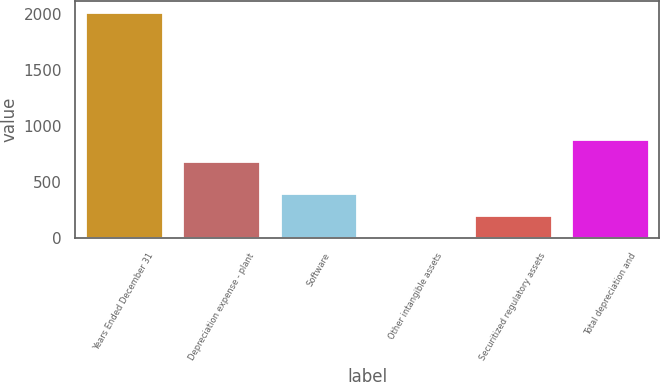Convert chart. <chart><loc_0><loc_0><loc_500><loc_500><bar_chart><fcel>Years Ended December 31<fcel>Depreciation expense - plant<fcel>Software<fcel>Other intangible assets<fcel>Securitized regulatory assets<fcel>Total depreciation and<nl><fcel>2016<fcel>687<fcel>405.6<fcel>3<fcel>204.3<fcel>888.3<nl></chart> 